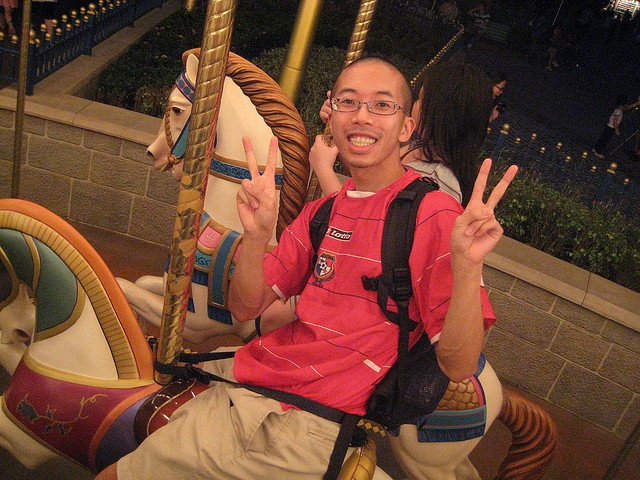Describe the objects in this image and their specific colors. I can see people in maroon, black, tan, and brown tones, horse in maroon, black, olive, and tan tones, horse in maroon, brown, and tan tones, backpack in maroon, black, brown, and navy tones, and people in maroon, black, salmon, and brown tones in this image. 